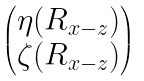<formula> <loc_0><loc_0><loc_500><loc_500>\begin{pmatrix} \eta ( R _ { x - z } ) \\ \zeta ( R _ { x - z } ) \end{pmatrix}</formula> 